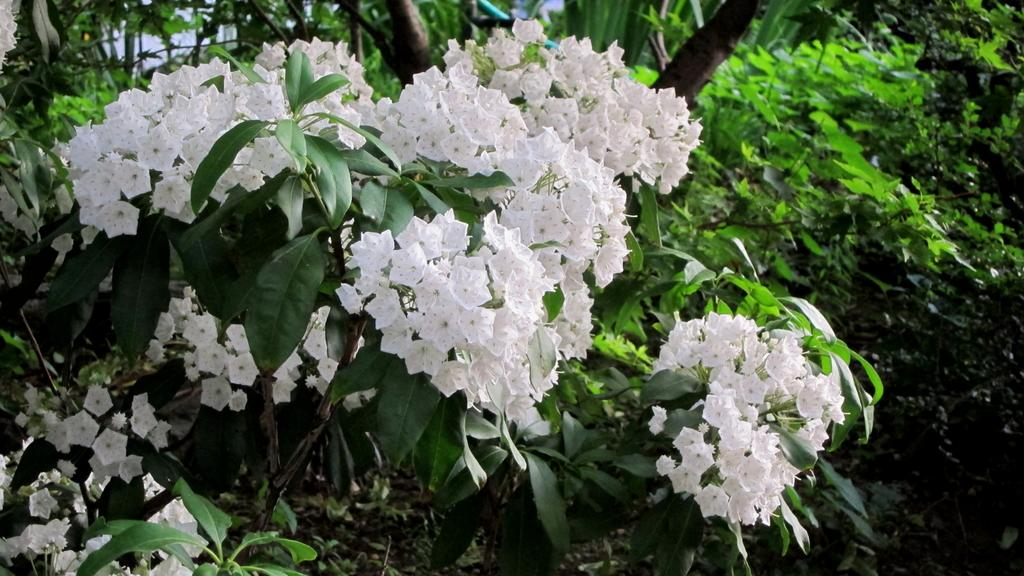What type of plant or tree is featured in the image? There is a plant or tree with flowers in the image. What color are the flowers on the plant or tree? The flowers are white. What can be seen in the background of the image? There are trees in the background of the image. Where might this image have been taken? The image might have been taken in a garden, given the presence of a plant or tree with flowers and trees in the background. How many docks are visible in the image? There are no docks present in the image. What time of day is it in the image, based on the hour? The image does not provide any information about the time of day, so it is impossible to determine the hour. 